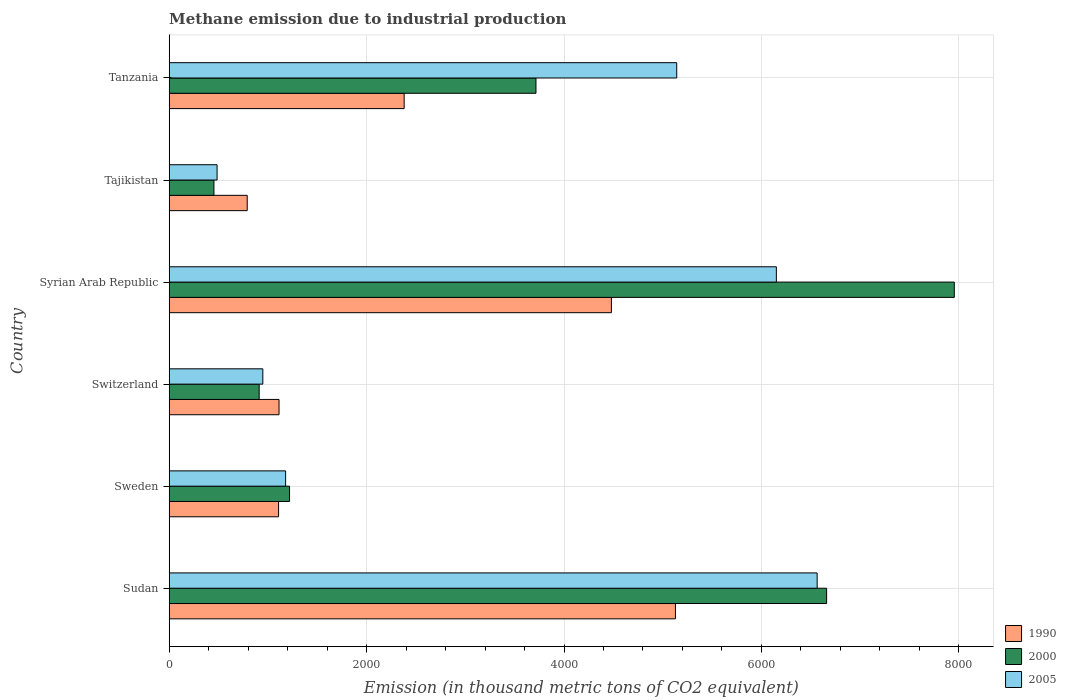How many groups of bars are there?
Keep it short and to the point. 6. Are the number of bars per tick equal to the number of legend labels?
Ensure brevity in your answer.  Yes. Are the number of bars on each tick of the Y-axis equal?
Offer a very short reply. Yes. How many bars are there on the 4th tick from the bottom?
Offer a very short reply. 3. What is the label of the 2nd group of bars from the top?
Provide a succinct answer. Tajikistan. In how many cases, is the number of bars for a given country not equal to the number of legend labels?
Your response must be concise. 0. What is the amount of methane emitted in 1990 in Switzerland?
Your answer should be very brief. 1112.7. Across all countries, what is the maximum amount of methane emitted in 1990?
Give a very brief answer. 5129.1. Across all countries, what is the minimum amount of methane emitted in 2000?
Provide a succinct answer. 453.3. In which country was the amount of methane emitted in 1990 maximum?
Keep it short and to the point. Sudan. In which country was the amount of methane emitted in 2005 minimum?
Provide a succinct answer. Tajikistan. What is the total amount of methane emitted in 1990 in the graph?
Offer a very short reply. 1.50e+04. What is the difference between the amount of methane emitted in 2000 in Sudan and that in Sweden?
Provide a succinct answer. 5441.6. What is the difference between the amount of methane emitted in 2000 in Sudan and the amount of methane emitted in 1990 in Tajikistan?
Offer a terse response. 5870.5. What is the average amount of methane emitted in 2000 per country?
Offer a terse response. 3485.97. What is the difference between the amount of methane emitted in 2005 and amount of methane emitted in 2000 in Sudan?
Keep it short and to the point. -95.8. In how many countries, is the amount of methane emitted in 1990 greater than 4000 thousand metric tons?
Your answer should be compact. 2. What is the ratio of the amount of methane emitted in 2000 in Switzerland to that in Tajikistan?
Your response must be concise. 2.01. Is the difference between the amount of methane emitted in 2005 in Syrian Arab Republic and Tajikistan greater than the difference between the amount of methane emitted in 2000 in Syrian Arab Republic and Tajikistan?
Offer a terse response. No. What is the difference between the highest and the second highest amount of methane emitted in 1990?
Offer a terse response. 648.9. What is the difference between the highest and the lowest amount of methane emitted in 1990?
Offer a terse response. 4338.7. Is the sum of the amount of methane emitted in 2005 in Switzerland and Tajikistan greater than the maximum amount of methane emitted in 2000 across all countries?
Ensure brevity in your answer.  No. What does the 3rd bar from the bottom in Tanzania represents?
Offer a terse response. 2005. Is it the case that in every country, the sum of the amount of methane emitted in 1990 and amount of methane emitted in 2005 is greater than the amount of methane emitted in 2000?
Provide a short and direct response. Yes. How many bars are there?
Your answer should be very brief. 18. Are the values on the major ticks of X-axis written in scientific E-notation?
Offer a very short reply. No. Does the graph contain grids?
Provide a succinct answer. Yes. How many legend labels are there?
Your answer should be very brief. 3. What is the title of the graph?
Your response must be concise. Methane emission due to industrial production. What is the label or title of the X-axis?
Offer a very short reply. Emission (in thousand metric tons of CO2 equivalent). What is the label or title of the Y-axis?
Your answer should be compact. Country. What is the Emission (in thousand metric tons of CO2 equivalent) in 1990 in Sudan?
Offer a terse response. 5129.1. What is the Emission (in thousand metric tons of CO2 equivalent) in 2000 in Sudan?
Your answer should be compact. 6660.9. What is the Emission (in thousand metric tons of CO2 equivalent) in 2005 in Sudan?
Give a very brief answer. 6565.1. What is the Emission (in thousand metric tons of CO2 equivalent) of 1990 in Sweden?
Your answer should be compact. 1108.1. What is the Emission (in thousand metric tons of CO2 equivalent) in 2000 in Sweden?
Provide a short and direct response. 1219.3. What is the Emission (in thousand metric tons of CO2 equivalent) of 2005 in Sweden?
Your answer should be very brief. 1179.4. What is the Emission (in thousand metric tons of CO2 equivalent) of 1990 in Switzerland?
Your answer should be compact. 1112.7. What is the Emission (in thousand metric tons of CO2 equivalent) in 2000 in Switzerland?
Your answer should be very brief. 911.6. What is the Emission (in thousand metric tons of CO2 equivalent) of 2005 in Switzerland?
Keep it short and to the point. 948.6. What is the Emission (in thousand metric tons of CO2 equivalent) in 1990 in Syrian Arab Republic?
Keep it short and to the point. 4480.2. What is the Emission (in thousand metric tons of CO2 equivalent) in 2000 in Syrian Arab Republic?
Give a very brief answer. 7954.6. What is the Emission (in thousand metric tons of CO2 equivalent) of 2005 in Syrian Arab Republic?
Offer a terse response. 6151.7. What is the Emission (in thousand metric tons of CO2 equivalent) in 1990 in Tajikistan?
Provide a succinct answer. 790.4. What is the Emission (in thousand metric tons of CO2 equivalent) in 2000 in Tajikistan?
Offer a very short reply. 453.3. What is the Emission (in thousand metric tons of CO2 equivalent) in 2005 in Tajikistan?
Your answer should be very brief. 485. What is the Emission (in thousand metric tons of CO2 equivalent) of 1990 in Tanzania?
Provide a short and direct response. 2380.6. What is the Emission (in thousand metric tons of CO2 equivalent) in 2000 in Tanzania?
Offer a very short reply. 3716.1. What is the Emission (in thousand metric tons of CO2 equivalent) of 2005 in Tanzania?
Your answer should be compact. 5142.2. Across all countries, what is the maximum Emission (in thousand metric tons of CO2 equivalent) in 1990?
Provide a short and direct response. 5129.1. Across all countries, what is the maximum Emission (in thousand metric tons of CO2 equivalent) of 2000?
Offer a terse response. 7954.6. Across all countries, what is the maximum Emission (in thousand metric tons of CO2 equivalent) of 2005?
Offer a terse response. 6565.1. Across all countries, what is the minimum Emission (in thousand metric tons of CO2 equivalent) in 1990?
Provide a succinct answer. 790.4. Across all countries, what is the minimum Emission (in thousand metric tons of CO2 equivalent) in 2000?
Offer a very short reply. 453.3. Across all countries, what is the minimum Emission (in thousand metric tons of CO2 equivalent) in 2005?
Give a very brief answer. 485. What is the total Emission (in thousand metric tons of CO2 equivalent) of 1990 in the graph?
Offer a very short reply. 1.50e+04. What is the total Emission (in thousand metric tons of CO2 equivalent) in 2000 in the graph?
Provide a succinct answer. 2.09e+04. What is the total Emission (in thousand metric tons of CO2 equivalent) of 2005 in the graph?
Offer a terse response. 2.05e+04. What is the difference between the Emission (in thousand metric tons of CO2 equivalent) of 1990 in Sudan and that in Sweden?
Your response must be concise. 4021. What is the difference between the Emission (in thousand metric tons of CO2 equivalent) in 2000 in Sudan and that in Sweden?
Offer a terse response. 5441.6. What is the difference between the Emission (in thousand metric tons of CO2 equivalent) of 2005 in Sudan and that in Sweden?
Provide a succinct answer. 5385.7. What is the difference between the Emission (in thousand metric tons of CO2 equivalent) of 1990 in Sudan and that in Switzerland?
Your response must be concise. 4016.4. What is the difference between the Emission (in thousand metric tons of CO2 equivalent) in 2000 in Sudan and that in Switzerland?
Offer a very short reply. 5749.3. What is the difference between the Emission (in thousand metric tons of CO2 equivalent) of 2005 in Sudan and that in Switzerland?
Offer a terse response. 5616.5. What is the difference between the Emission (in thousand metric tons of CO2 equivalent) of 1990 in Sudan and that in Syrian Arab Republic?
Provide a short and direct response. 648.9. What is the difference between the Emission (in thousand metric tons of CO2 equivalent) of 2000 in Sudan and that in Syrian Arab Republic?
Make the answer very short. -1293.7. What is the difference between the Emission (in thousand metric tons of CO2 equivalent) in 2005 in Sudan and that in Syrian Arab Republic?
Provide a succinct answer. 413.4. What is the difference between the Emission (in thousand metric tons of CO2 equivalent) in 1990 in Sudan and that in Tajikistan?
Your answer should be very brief. 4338.7. What is the difference between the Emission (in thousand metric tons of CO2 equivalent) of 2000 in Sudan and that in Tajikistan?
Your answer should be compact. 6207.6. What is the difference between the Emission (in thousand metric tons of CO2 equivalent) in 2005 in Sudan and that in Tajikistan?
Give a very brief answer. 6080.1. What is the difference between the Emission (in thousand metric tons of CO2 equivalent) of 1990 in Sudan and that in Tanzania?
Your answer should be compact. 2748.5. What is the difference between the Emission (in thousand metric tons of CO2 equivalent) in 2000 in Sudan and that in Tanzania?
Offer a very short reply. 2944.8. What is the difference between the Emission (in thousand metric tons of CO2 equivalent) of 2005 in Sudan and that in Tanzania?
Your response must be concise. 1422.9. What is the difference between the Emission (in thousand metric tons of CO2 equivalent) of 2000 in Sweden and that in Switzerland?
Your answer should be compact. 307.7. What is the difference between the Emission (in thousand metric tons of CO2 equivalent) in 2005 in Sweden and that in Switzerland?
Your answer should be compact. 230.8. What is the difference between the Emission (in thousand metric tons of CO2 equivalent) in 1990 in Sweden and that in Syrian Arab Republic?
Offer a very short reply. -3372.1. What is the difference between the Emission (in thousand metric tons of CO2 equivalent) in 2000 in Sweden and that in Syrian Arab Republic?
Your response must be concise. -6735.3. What is the difference between the Emission (in thousand metric tons of CO2 equivalent) of 2005 in Sweden and that in Syrian Arab Republic?
Ensure brevity in your answer.  -4972.3. What is the difference between the Emission (in thousand metric tons of CO2 equivalent) in 1990 in Sweden and that in Tajikistan?
Provide a short and direct response. 317.7. What is the difference between the Emission (in thousand metric tons of CO2 equivalent) in 2000 in Sweden and that in Tajikistan?
Keep it short and to the point. 766. What is the difference between the Emission (in thousand metric tons of CO2 equivalent) of 2005 in Sweden and that in Tajikistan?
Give a very brief answer. 694.4. What is the difference between the Emission (in thousand metric tons of CO2 equivalent) of 1990 in Sweden and that in Tanzania?
Provide a short and direct response. -1272.5. What is the difference between the Emission (in thousand metric tons of CO2 equivalent) of 2000 in Sweden and that in Tanzania?
Keep it short and to the point. -2496.8. What is the difference between the Emission (in thousand metric tons of CO2 equivalent) of 2005 in Sweden and that in Tanzania?
Make the answer very short. -3962.8. What is the difference between the Emission (in thousand metric tons of CO2 equivalent) of 1990 in Switzerland and that in Syrian Arab Republic?
Your response must be concise. -3367.5. What is the difference between the Emission (in thousand metric tons of CO2 equivalent) in 2000 in Switzerland and that in Syrian Arab Republic?
Provide a succinct answer. -7043. What is the difference between the Emission (in thousand metric tons of CO2 equivalent) in 2005 in Switzerland and that in Syrian Arab Republic?
Offer a very short reply. -5203.1. What is the difference between the Emission (in thousand metric tons of CO2 equivalent) of 1990 in Switzerland and that in Tajikistan?
Provide a succinct answer. 322.3. What is the difference between the Emission (in thousand metric tons of CO2 equivalent) of 2000 in Switzerland and that in Tajikistan?
Offer a very short reply. 458.3. What is the difference between the Emission (in thousand metric tons of CO2 equivalent) in 2005 in Switzerland and that in Tajikistan?
Your answer should be compact. 463.6. What is the difference between the Emission (in thousand metric tons of CO2 equivalent) of 1990 in Switzerland and that in Tanzania?
Give a very brief answer. -1267.9. What is the difference between the Emission (in thousand metric tons of CO2 equivalent) of 2000 in Switzerland and that in Tanzania?
Give a very brief answer. -2804.5. What is the difference between the Emission (in thousand metric tons of CO2 equivalent) of 2005 in Switzerland and that in Tanzania?
Give a very brief answer. -4193.6. What is the difference between the Emission (in thousand metric tons of CO2 equivalent) of 1990 in Syrian Arab Republic and that in Tajikistan?
Offer a terse response. 3689.8. What is the difference between the Emission (in thousand metric tons of CO2 equivalent) in 2000 in Syrian Arab Republic and that in Tajikistan?
Ensure brevity in your answer.  7501.3. What is the difference between the Emission (in thousand metric tons of CO2 equivalent) in 2005 in Syrian Arab Republic and that in Tajikistan?
Offer a terse response. 5666.7. What is the difference between the Emission (in thousand metric tons of CO2 equivalent) in 1990 in Syrian Arab Republic and that in Tanzania?
Offer a very short reply. 2099.6. What is the difference between the Emission (in thousand metric tons of CO2 equivalent) of 2000 in Syrian Arab Republic and that in Tanzania?
Offer a very short reply. 4238.5. What is the difference between the Emission (in thousand metric tons of CO2 equivalent) of 2005 in Syrian Arab Republic and that in Tanzania?
Provide a succinct answer. 1009.5. What is the difference between the Emission (in thousand metric tons of CO2 equivalent) in 1990 in Tajikistan and that in Tanzania?
Give a very brief answer. -1590.2. What is the difference between the Emission (in thousand metric tons of CO2 equivalent) of 2000 in Tajikistan and that in Tanzania?
Ensure brevity in your answer.  -3262.8. What is the difference between the Emission (in thousand metric tons of CO2 equivalent) in 2005 in Tajikistan and that in Tanzania?
Give a very brief answer. -4657.2. What is the difference between the Emission (in thousand metric tons of CO2 equivalent) of 1990 in Sudan and the Emission (in thousand metric tons of CO2 equivalent) of 2000 in Sweden?
Your answer should be compact. 3909.8. What is the difference between the Emission (in thousand metric tons of CO2 equivalent) of 1990 in Sudan and the Emission (in thousand metric tons of CO2 equivalent) of 2005 in Sweden?
Give a very brief answer. 3949.7. What is the difference between the Emission (in thousand metric tons of CO2 equivalent) in 2000 in Sudan and the Emission (in thousand metric tons of CO2 equivalent) in 2005 in Sweden?
Keep it short and to the point. 5481.5. What is the difference between the Emission (in thousand metric tons of CO2 equivalent) of 1990 in Sudan and the Emission (in thousand metric tons of CO2 equivalent) of 2000 in Switzerland?
Make the answer very short. 4217.5. What is the difference between the Emission (in thousand metric tons of CO2 equivalent) in 1990 in Sudan and the Emission (in thousand metric tons of CO2 equivalent) in 2005 in Switzerland?
Provide a short and direct response. 4180.5. What is the difference between the Emission (in thousand metric tons of CO2 equivalent) of 2000 in Sudan and the Emission (in thousand metric tons of CO2 equivalent) of 2005 in Switzerland?
Provide a succinct answer. 5712.3. What is the difference between the Emission (in thousand metric tons of CO2 equivalent) of 1990 in Sudan and the Emission (in thousand metric tons of CO2 equivalent) of 2000 in Syrian Arab Republic?
Offer a terse response. -2825.5. What is the difference between the Emission (in thousand metric tons of CO2 equivalent) of 1990 in Sudan and the Emission (in thousand metric tons of CO2 equivalent) of 2005 in Syrian Arab Republic?
Keep it short and to the point. -1022.6. What is the difference between the Emission (in thousand metric tons of CO2 equivalent) in 2000 in Sudan and the Emission (in thousand metric tons of CO2 equivalent) in 2005 in Syrian Arab Republic?
Your response must be concise. 509.2. What is the difference between the Emission (in thousand metric tons of CO2 equivalent) in 1990 in Sudan and the Emission (in thousand metric tons of CO2 equivalent) in 2000 in Tajikistan?
Ensure brevity in your answer.  4675.8. What is the difference between the Emission (in thousand metric tons of CO2 equivalent) in 1990 in Sudan and the Emission (in thousand metric tons of CO2 equivalent) in 2005 in Tajikistan?
Ensure brevity in your answer.  4644.1. What is the difference between the Emission (in thousand metric tons of CO2 equivalent) of 2000 in Sudan and the Emission (in thousand metric tons of CO2 equivalent) of 2005 in Tajikistan?
Your response must be concise. 6175.9. What is the difference between the Emission (in thousand metric tons of CO2 equivalent) in 1990 in Sudan and the Emission (in thousand metric tons of CO2 equivalent) in 2000 in Tanzania?
Offer a very short reply. 1413. What is the difference between the Emission (in thousand metric tons of CO2 equivalent) of 1990 in Sudan and the Emission (in thousand metric tons of CO2 equivalent) of 2005 in Tanzania?
Your answer should be compact. -13.1. What is the difference between the Emission (in thousand metric tons of CO2 equivalent) in 2000 in Sudan and the Emission (in thousand metric tons of CO2 equivalent) in 2005 in Tanzania?
Provide a succinct answer. 1518.7. What is the difference between the Emission (in thousand metric tons of CO2 equivalent) in 1990 in Sweden and the Emission (in thousand metric tons of CO2 equivalent) in 2000 in Switzerland?
Ensure brevity in your answer.  196.5. What is the difference between the Emission (in thousand metric tons of CO2 equivalent) in 1990 in Sweden and the Emission (in thousand metric tons of CO2 equivalent) in 2005 in Switzerland?
Your response must be concise. 159.5. What is the difference between the Emission (in thousand metric tons of CO2 equivalent) in 2000 in Sweden and the Emission (in thousand metric tons of CO2 equivalent) in 2005 in Switzerland?
Keep it short and to the point. 270.7. What is the difference between the Emission (in thousand metric tons of CO2 equivalent) of 1990 in Sweden and the Emission (in thousand metric tons of CO2 equivalent) of 2000 in Syrian Arab Republic?
Make the answer very short. -6846.5. What is the difference between the Emission (in thousand metric tons of CO2 equivalent) in 1990 in Sweden and the Emission (in thousand metric tons of CO2 equivalent) in 2005 in Syrian Arab Republic?
Keep it short and to the point. -5043.6. What is the difference between the Emission (in thousand metric tons of CO2 equivalent) of 2000 in Sweden and the Emission (in thousand metric tons of CO2 equivalent) of 2005 in Syrian Arab Republic?
Ensure brevity in your answer.  -4932.4. What is the difference between the Emission (in thousand metric tons of CO2 equivalent) in 1990 in Sweden and the Emission (in thousand metric tons of CO2 equivalent) in 2000 in Tajikistan?
Your answer should be very brief. 654.8. What is the difference between the Emission (in thousand metric tons of CO2 equivalent) in 1990 in Sweden and the Emission (in thousand metric tons of CO2 equivalent) in 2005 in Tajikistan?
Your response must be concise. 623.1. What is the difference between the Emission (in thousand metric tons of CO2 equivalent) of 2000 in Sweden and the Emission (in thousand metric tons of CO2 equivalent) of 2005 in Tajikistan?
Provide a succinct answer. 734.3. What is the difference between the Emission (in thousand metric tons of CO2 equivalent) in 1990 in Sweden and the Emission (in thousand metric tons of CO2 equivalent) in 2000 in Tanzania?
Make the answer very short. -2608. What is the difference between the Emission (in thousand metric tons of CO2 equivalent) in 1990 in Sweden and the Emission (in thousand metric tons of CO2 equivalent) in 2005 in Tanzania?
Give a very brief answer. -4034.1. What is the difference between the Emission (in thousand metric tons of CO2 equivalent) of 2000 in Sweden and the Emission (in thousand metric tons of CO2 equivalent) of 2005 in Tanzania?
Offer a very short reply. -3922.9. What is the difference between the Emission (in thousand metric tons of CO2 equivalent) of 1990 in Switzerland and the Emission (in thousand metric tons of CO2 equivalent) of 2000 in Syrian Arab Republic?
Offer a very short reply. -6841.9. What is the difference between the Emission (in thousand metric tons of CO2 equivalent) of 1990 in Switzerland and the Emission (in thousand metric tons of CO2 equivalent) of 2005 in Syrian Arab Republic?
Give a very brief answer. -5039. What is the difference between the Emission (in thousand metric tons of CO2 equivalent) in 2000 in Switzerland and the Emission (in thousand metric tons of CO2 equivalent) in 2005 in Syrian Arab Republic?
Offer a terse response. -5240.1. What is the difference between the Emission (in thousand metric tons of CO2 equivalent) in 1990 in Switzerland and the Emission (in thousand metric tons of CO2 equivalent) in 2000 in Tajikistan?
Provide a short and direct response. 659.4. What is the difference between the Emission (in thousand metric tons of CO2 equivalent) in 1990 in Switzerland and the Emission (in thousand metric tons of CO2 equivalent) in 2005 in Tajikistan?
Provide a succinct answer. 627.7. What is the difference between the Emission (in thousand metric tons of CO2 equivalent) of 2000 in Switzerland and the Emission (in thousand metric tons of CO2 equivalent) of 2005 in Tajikistan?
Give a very brief answer. 426.6. What is the difference between the Emission (in thousand metric tons of CO2 equivalent) in 1990 in Switzerland and the Emission (in thousand metric tons of CO2 equivalent) in 2000 in Tanzania?
Make the answer very short. -2603.4. What is the difference between the Emission (in thousand metric tons of CO2 equivalent) of 1990 in Switzerland and the Emission (in thousand metric tons of CO2 equivalent) of 2005 in Tanzania?
Your answer should be very brief. -4029.5. What is the difference between the Emission (in thousand metric tons of CO2 equivalent) in 2000 in Switzerland and the Emission (in thousand metric tons of CO2 equivalent) in 2005 in Tanzania?
Your response must be concise. -4230.6. What is the difference between the Emission (in thousand metric tons of CO2 equivalent) in 1990 in Syrian Arab Republic and the Emission (in thousand metric tons of CO2 equivalent) in 2000 in Tajikistan?
Offer a very short reply. 4026.9. What is the difference between the Emission (in thousand metric tons of CO2 equivalent) in 1990 in Syrian Arab Republic and the Emission (in thousand metric tons of CO2 equivalent) in 2005 in Tajikistan?
Give a very brief answer. 3995.2. What is the difference between the Emission (in thousand metric tons of CO2 equivalent) of 2000 in Syrian Arab Republic and the Emission (in thousand metric tons of CO2 equivalent) of 2005 in Tajikistan?
Make the answer very short. 7469.6. What is the difference between the Emission (in thousand metric tons of CO2 equivalent) in 1990 in Syrian Arab Republic and the Emission (in thousand metric tons of CO2 equivalent) in 2000 in Tanzania?
Your answer should be very brief. 764.1. What is the difference between the Emission (in thousand metric tons of CO2 equivalent) in 1990 in Syrian Arab Republic and the Emission (in thousand metric tons of CO2 equivalent) in 2005 in Tanzania?
Your answer should be compact. -662. What is the difference between the Emission (in thousand metric tons of CO2 equivalent) in 2000 in Syrian Arab Republic and the Emission (in thousand metric tons of CO2 equivalent) in 2005 in Tanzania?
Provide a succinct answer. 2812.4. What is the difference between the Emission (in thousand metric tons of CO2 equivalent) of 1990 in Tajikistan and the Emission (in thousand metric tons of CO2 equivalent) of 2000 in Tanzania?
Provide a short and direct response. -2925.7. What is the difference between the Emission (in thousand metric tons of CO2 equivalent) of 1990 in Tajikistan and the Emission (in thousand metric tons of CO2 equivalent) of 2005 in Tanzania?
Offer a very short reply. -4351.8. What is the difference between the Emission (in thousand metric tons of CO2 equivalent) of 2000 in Tajikistan and the Emission (in thousand metric tons of CO2 equivalent) of 2005 in Tanzania?
Offer a very short reply. -4688.9. What is the average Emission (in thousand metric tons of CO2 equivalent) in 1990 per country?
Your answer should be very brief. 2500.18. What is the average Emission (in thousand metric tons of CO2 equivalent) of 2000 per country?
Offer a terse response. 3485.97. What is the average Emission (in thousand metric tons of CO2 equivalent) in 2005 per country?
Make the answer very short. 3412. What is the difference between the Emission (in thousand metric tons of CO2 equivalent) of 1990 and Emission (in thousand metric tons of CO2 equivalent) of 2000 in Sudan?
Provide a succinct answer. -1531.8. What is the difference between the Emission (in thousand metric tons of CO2 equivalent) in 1990 and Emission (in thousand metric tons of CO2 equivalent) in 2005 in Sudan?
Your response must be concise. -1436. What is the difference between the Emission (in thousand metric tons of CO2 equivalent) in 2000 and Emission (in thousand metric tons of CO2 equivalent) in 2005 in Sudan?
Offer a terse response. 95.8. What is the difference between the Emission (in thousand metric tons of CO2 equivalent) in 1990 and Emission (in thousand metric tons of CO2 equivalent) in 2000 in Sweden?
Give a very brief answer. -111.2. What is the difference between the Emission (in thousand metric tons of CO2 equivalent) of 1990 and Emission (in thousand metric tons of CO2 equivalent) of 2005 in Sweden?
Your answer should be very brief. -71.3. What is the difference between the Emission (in thousand metric tons of CO2 equivalent) of 2000 and Emission (in thousand metric tons of CO2 equivalent) of 2005 in Sweden?
Offer a terse response. 39.9. What is the difference between the Emission (in thousand metric tons of CO2 equivalent) of 1990 and Emission (in thousand metric tons of CO2 equivalent) of 2000 in Switzerland?
Your answer should be compact. 201.1. What is the difference between the Emission (in thousand metric tons of CO2 equivalent) in 1990 and Emission (in thousand metric tons of CO2 equivalent) in 2005 in Switzerland?
Your answer should be very brief. 164.1. What is the difference between the Emission (in thousand metric tons of CO2 equivalent) of 2000 and Emission (in thousand metric tons of CO2 equivalent) of 2005 in Switzerland?
Offer a very short reply. -37. What is the difference between the Emission (in thousand metric tons of CO2 equivalent) of 1990 and Emission (in thousand metric tons of CO2 equivalent) of 2000 in Syrian Arab Republic?
Ensure brevity in your answer.  -3474.4. What is the difference between the Emission (in thousand metric tons of CO2 equivalent) of 1990 and Emission (in thousand metric tons of CO2 equivalent) of 2005 in Syrian Arab Republic?
Give a very brief answer. -1671.5. What is the difference between the Emission (in thousand metric tons of CO2 equivalent) in 2000 and Emission (in thousand metric tons of CO2 equivalent) in 2005 in Syrian Arab Republic?
Offer a very short reply. 1802.9. What is the difference between the Emission (in thousand metric tons of CO2 equivalent) in 1990 and Emission (in thousand metric tons of CO2 equivalent) in 2000 in Tajikistan?
Keep it short and to the point. 337.1. What is the difference between the Emission (in thousand metric tons of CO2 equivalent) in 1990 and Emission (in thousand metric tons of CO2 equivalent) in 2005 in Tajikistan?
Make the answer very short. 305.4. What is the difference between the Emission (in thousand metric tons of CO2 equivalent) of 2000 and Emission (in thousand metric tons of CO2 equivalent) of 2005 in Tajikistan?
Provide a succinct answer. -31.7. What is the difference between the Emission (in thousand metric tons of CO2 equivalent) in 1990 and Emission (in thousand metric tons of CO2 equivalent) in 2000 in Tanzania?
Provide a succinct answer. -1335.5. What is the difference between the Emission (in thousand metric tons of CO2 equivalent) of 1990 and Emission (in thousand metric tons of CO2 equivalent) of 2005 in Tanzania?
Your response must be concise. -2761.6. What is the difference between the Emission (in thousand metric tons of CO2 equivalent) of 2000 and Emission (in thousand metric tons of CO2 equivalent) of 2005 in Tanzania?
Ensure brevity in your answer.  -1426.1. What is the ratio of the Emission (in thousand metric tons of CO2 equivalent) of 1990 in Sudan to that in Sweden?
Your answer should be compact. 4.63. What is the ratio of the Emission (in thousand metric tons of CO2 equivalent) of 2000 in Sudan to that in Sweden?
Make the answer very short. 5.46. What is the ratio of the Emission (in thousand metric tons of CO2 equivalent) of 2005 in Sudan to that in Sweden?
Your answer should be compact. 5.57. What is the ratio of the Emission (in thousand metric tons of CO2 equivalent) of 1990 in Sudan to that in Switzerland?
Offer a terse response. 4.61. What is the ratio of the Emission (in thousand metric tons of CO2 equivalent) of 2000 in Sudan to that in Switzerland?
Give a very brief answer. 7.31. What is the ratio of the Emission (in thousand metric tons of CO2 equivalent) of 2005 in Sudan to that in Switzerland?
Offer a very short reply. 6.92. What is the ratio of the Emission (in thousand metric tons of CO2 equivalent) of 1990 in Sudan to that in Syrian Arab Republic?
Offer a terse response. 1.14. What is the ratio of the Emission (in thousand metric tons of CO2 equivalent) of 2000 in Sudan to that in Syrian Arab Republic?
Your answer should be compact. 0.84. What is the ratio of the Emission (in thousand metric tons of CO2 equivalent) in 2005 in Sudan to that in Syrian Arab Republic?
Your answer should be very brief. 1.07. What is the ratio of the Emission (in thousand metric tons of CO2 equivalent) of 1990 in Sudan to that in Tajikistan?
Provide a succinct answer. 6.49. What is the ratio of the Emission (in thousand metric tons of CO2 equivalent) of 2000 in Sudan to that in Tajikistan?
Offer a very short reply. 14.69. What is the ratio of the Emission (in thousand metric tons of CO2 equivalent) of 2005 in Sudan to that in Tajikistan?
Your answer should be compact. 13.54. What is the ratio of the Emission (in thousand metric tons of CO2 equivalent) of 1990 in Sudan to that in Tanzania?
Your answer should be compact. 2.15. What is the ratio of the Emission (in thousand metric tons of CO2 equivalent) in 2000 in Sudan to that in Tanzania?
Offer a very short reply. 1.79. What is the ratio of the Emission (in thousand metric tons of CO2 equivalent) of 2005 in Sudan to that in Tanzania?
Offer a terse response. 1.28. What is the ratio of the Emission (in thousand metric tons of CO2 equivalent) of 2000 in Sweden to that in Switzerland?
Ensure brevity in your answer.  1.34. What is the ratio of the Emission (in thousand metric tons of CO2 equivalent) of 2005 in Sweden to that in Switzerland?
Give a very brief answer. 1.24. What is the ratio of the Emission (in thousand metric tons of CO2 equivalent) in 1990 in Sweden to that in Syrian Arab Republic?
Your answer should be very brief. 0.25. What is the ratio of the Emission (in thousand metric tons of CO2 equivalent) of 2000 in Sweden to that in Syrian Arab Republic?
Ensure brevity in your answer.  0.15. What is the ratio of the Emission (in thousand metric tons of CO2 equivalent) of 2005 in Sweden to that in Syrian Arab Republic?
Ensure brevity in your answer.  0.19. What is the ratio of the Emission (in thousand metric tons of CO2 equivalent) in 1990 in Sweden to that in Tajikistan?
Your answer should be very brief. 1.4. What is the ratio of the Emission (in thousand metric tons of CO2 equivalent) of 2000 in Sweden to that in Tajikistan?
Offer a very short reply. 2.69. What is the ratio of the Emission (in thousand metric tons of CO2 equivalent) in 2005 in Sweden to that in Tajikistan?
Provide a short and direct response. 2.43. What is the ratio of the Emission (in thousand metric tons of CO2 equivalent) in 1990 in Sweden to that in Tanzania?
Keep it short and to the point. 0.47. What is the ratio of the Emission (in thousand metric tons of CO2 equivalent) of 2000 in Sweden to that in Tanzania?
Offer a terse response. 0.33. What is the ratio of the Emission (in thousand metric tons of CO2 equivalent) of 2005 in Sweden to that in Tanzania?
Your answer should be compact. 0.23. What is the ratio of the Emission (in thousand metric tons of CO2 equivalent) of 1990 in Switzerland to that in Syrian Arab Republic?
Offer a very short reply. 0.25. What is the ratio of the Emission (in thousand metric tons of CO2 equivalent) in 2000 in Switzerland to that in Syrian Arab Republic?
Your answer should be very brief. 0.11. What is the ratio of the Emission (in thousand metric tons of CO2 equivalent) in 2005 in Switzerland to that in Syrian Arab Republic?
Your response must be concise. 0.15. What is the ratio of the Emission (in thousand metric tons of CO2 equivalent) in 1990 in Switzerland to that in Tajikistan?
Your answer should be compact. 1.41. What is the ratio of the Emission (in thousand metric tons of CO2 equivalent) in 2000 in Switzerland to that in Tajikistan?
Provide a short and direct response. 2.01. What is the ratio of the Emission (in thousand metric tons of CO2 equivalent) in 2005 in Switzerland to that in Tajikistan?
Your response must be concise. 1.96. What is the ratio of the Emission (in thousand metric tons of CO2 equivalent) in 1990 in Switzerland to that in Tanzania?
Ensure brevity in your answer.  0.47. What is the ratio of the Emission (in thousand metric tons of CO2 equivalent) in 2000 in Switzerland to that in Tanzania?
Ensure brevity in your answer.  0.25. What is the ratio of the Emission (in thousand metric tons of CO2 equivalent) of 2005 in Switzerland to that in Tanzania?
Your answer should be very brief. 0.18. What is the ratio of the Emission (in thousand metric tons of CO2 equivalent) in 1990 in Syrian Arab Republic to that in Tajikistan?
Your answer should be very brief. 5.67. What is the ratio of the Emission (in thousand metric tons of CO2 equivalent) of 2000 in Syrian Arab Republic to that in Tajikistan?
Your answer should be compact. 17.55. What is the ratio of the Emission (in thousand metric tons of CO2 equivalent) in 2005 in Syrian Arab Republic to that in Tajikistan?
Make the answer very short. 12.68. What is the ratio of the Emission (in thousand metric tons of CO2 equivalent) of 1990 in Syrian Arab Republic to that in Tanzania?
Your response must be concise. 1.88. What is the ratio of the Emission (in thousand metric tons of CO2 equivalent) of 2000 in Syrian Arab Republic to that in Tanzania?
Ensure brevity in your answer.  2.14. What is the ratio of the Emission (in thousand metric tons of CO2 equivalent) of 2005 in Syrian Arab Republic to that in Tanzania?
Keep it short and to the point. 1.2. What is the ratio of the Emission (in thousand metric tons of CO2 equivalent) of 1990 in Tajikistan to that in Tanzania?
Make the answer very short. 0.33. What is the ratio of the Emission (in thousand metric tons of CO2 equivalent) in 2000 in Tajikistan to that in Tanzania?
Provide a succinct answer. 0.12. What is the ratio of the Emission (in thousand metric tons of CO2 equivalent) in 2005 in Tajikistan to that in Tanzania?
Your answer should be very brief. 0.09. What is the difference between the highest and the second highest Emission (in thousand metric tons of CO2 equivalent) of 1990?
Offer a very short reply. 648.9. What is the difference between the highest and the second highest Emission (in thousand metric tons of CO2 equivalent) in 2000?
Ensure brevity in your answer.  1293.7. What is the difference between the highest and the second highest Emission (in thousand metric tons of CO2 equivalent) in 2005?
Provide a succinct answer. 413.4. What is the difference between the highest and the lowest Emission (in thousand metric tons of CO2 equivalent) in 1990?
Give a very brief answer. 4338.7. What is the difference between the highest and the lowest Emission (in thousand metric tons of CO2 equivalent) of 2000?
Keep it short and to the point. 7501.3. What is the difference between the highest and the lowest Emission (in thousand metric tons of CO2 equivalent) in 2005?
Your answer should be compact. 6080.1. 